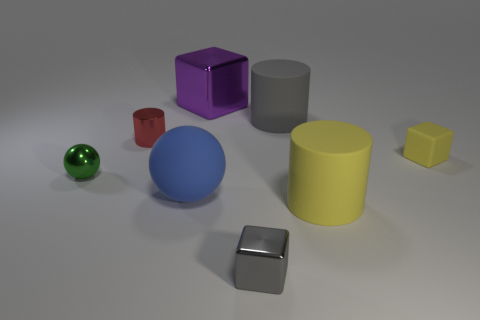Add 2 tiny cyan metal objects. How many objects exist? 10 Subtract all cylinders. How many objects are left? 5 Subtract 0 green cylinders. How many objects are left? 8 Subtract all red metallic objects. Subtract all purple shiny cubes. How many objects are left? 6 Add 7 small red metallic cylinders. How many small red metallic cylinders are left? 8 Add 1 tiny cyan spheres. How many tiny cyan spheres exist? 1 